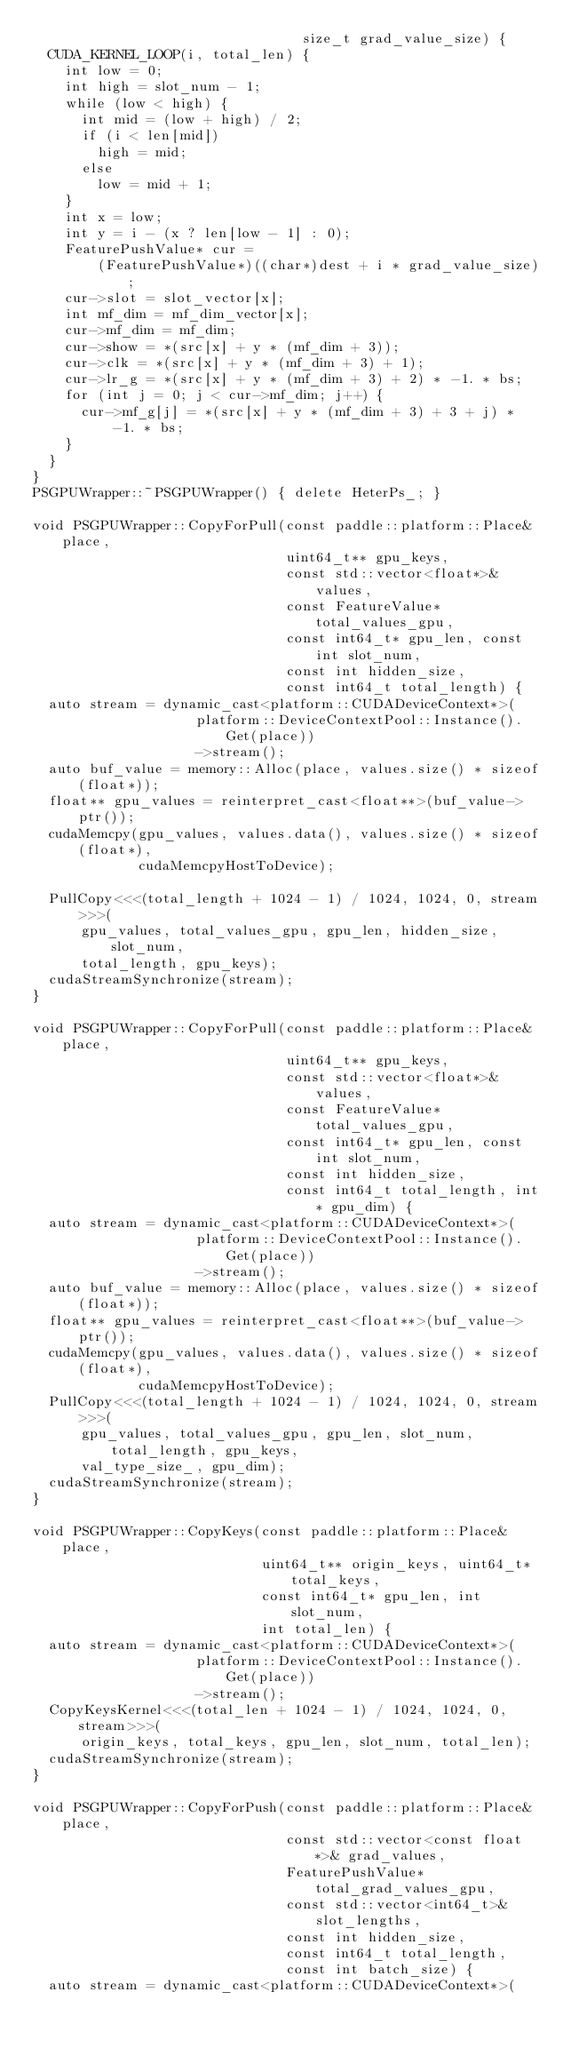<code> <loc_0><loc_0><loc_500><loc_500><_Cuda_>                                 size_t grad_value_size) {
  CUDA_KERNEL_LOOP(i, total_len) {
    int low = 0;
    int high = slot_num - 1;
    while (low < high) {
      int mid = (low + high) / 2;
      if (i < len[mid])
        high = mid;
      else
        low = mid + 1;
    }
    int x = low;
    int y = i - (x ? len[low - 1] : 0);
    FeaturePushValue* cur =
        (FeaturePushValue*)((char*)dest + i * grad_value_size);
    cur->slot = slot_vector[x];
    int mf_dim = mf_dim_vector[x];
    cur->mf_dim = mf_dim;
    cur->show = *(src[x] + y * (mf_dim + 3));
    cur->clk = *(src[x] + y * (mf_dim + 3) + 1);
    cur->lr_g = *(src[x] + y * (mf_dim + 3) + 2) * -1. * bs;
    for (int j = 0; j < cur->mf_dim; j++) {
      cur->mf_g[j] = *(src[x] + y * (mf_dim + 3) + 3 + j) * -1. * bs;
    }
  }
}
PSGPUWrapper::~PSGPUWrapper() { delete HeterPs_; }

void PSGPUWrapper::CopyForPull(const paddle::platform::Place& place,
                               uint64_t** gpu_keys,
                               const std::vector<float*>& values,
                               const FeatureValue* total_values_gpu,
                               const int64_t* gpu_len, const int slot_num,
                               const int hidden_size,
                               const int64_t total_length) {
  auto stream = dynamic_cast<platform::CUDADeviceContext*>(
                    platform::DeviceContextPool::Instance().Get(place))
                    ->stream();
  auto buf_value = memory::Alloc(place, values.size() * sizeof(float*));
  float** gpu_values = reinterpret_cast<float**>(buf_value->ptr());
  cudaMemcpy(gpu_values, values.data(), values.size() * sizeof(float*),
             cudaMemcpyHostToDevice);

  PullCopy<<<(total_length + 1024 - 1) / 1024, 1024, 0, stream>>>(
      gpu_values, total_values_gpu, gpu_len, hidden_size, slot_num,
      total_length, gpu_keys);
  cudaStreamSynchronize(stream);
}

void PSGPUWrapper::CopyForPull(const paddle::platform::Place& place,
                               uint64_t** gpu_keys,
                               const std::vector<float*>& values,
                               const FeatureValue* total_values_gpu,
                               const int64_t* gpu_len, const int slot_num,
                               const int hidden_size,
                               const int64_t total_length, int* gpu_dim) {
  auto stream = dynamic_cast<platform::CUDADeviceContext*>(
                    platform::DeviceContextPool::Instance().Get(place))
                    ->stream();
  auto buf_value = memory::Alloc(place, values.size() * sizeof(float*));
  float** gpu_values = reinterpret_cast<float**>(buf_value->ptr());
  cudaMemcpy(gpu_values, values.data(), values.size() * sizeof(float*),
             cudaMemcpyHostToDevice);
  PullCopy<<<(total_length + 1024 - 1) / 1024, 1024, 0, stream>>>(
      gpu_values, total_values_gpu, gpu_len, slot_num, total_length, gpu_keys,
      val_type_size_, gpu_dim);
  cudaStreamSynchronize(stream);
}

void PSGPUWrapper::CopyKeys(const paddle::platform::Place& place,
                            uint64_t** origin_keys, uint64_t* total_keys,
                            const int64_t* gpu_len, int slot_num,
                            int total_len) {
  auto stream = dynamic_cast<platform::CUDADeviceContext*>(
                    platform::DeviceContextPool::Instance().Get(place))
                    ->stream();
  CopyKeysKernel<<<(total_len + 1024 - 1) / 1024, 1024, 0, stream>>>(
      origin_keys, total_keys, gpu_len, slot_num, total_len);
  cudaStreamSynchronize(stream);
}

void PSGPUWrapper::CopyForPush(const paddle::platform::Place& place,
                               const std::vector<const float*>& grad_values,
                               FeaturePushValue* total_grad_values_gpu,
                               const std::vector<int64_t>& slot_lengths,
                               const int hidden_size,
                               const int64_t total_length,
                               const int batch_size) {
  auto stream = dynamic_cast<platform::CUDADeviceContext*>(</code> 